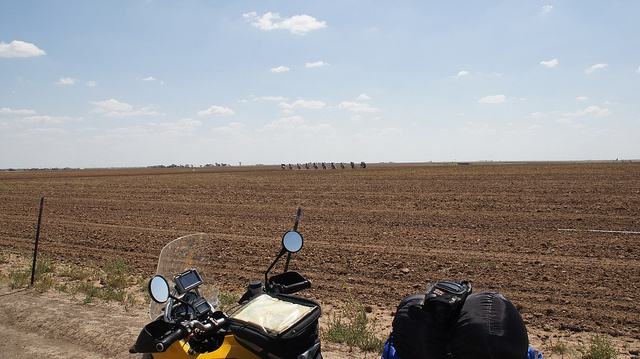Describe the objects in this image and their specific colors. I can see motorcycle in darkgray, black, gray, and beige tones, backpack in darkgray, black, and gray tones, and backpack in darkgray, black, beige, and gray tones in this image. 